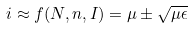Convert formula to latex. <formula><loc_0><loc_0><loc_500><loc_500>i \approx f ( N , n , I ) = \mu \pm \sqrt { \mu \epsilon }</formula> 